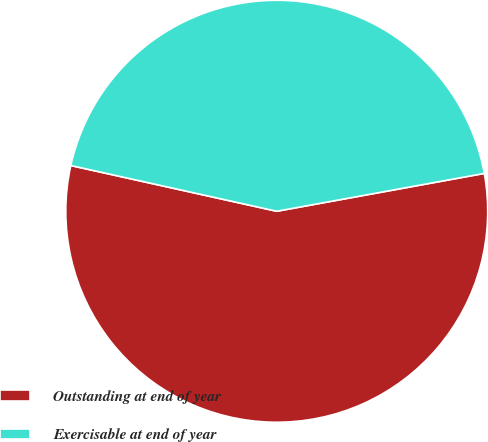Convert chart. <chart><loc_0><loc_0><loc_500><loc_500><pie_chart><fcel>Outstanding at end of year<fcel>Exercisable at end of year<nl><fcel>56.35%<fcel>43.65%<nl></chart> 